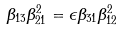Convert formula to latex. <formula><loc_0><loc_0><loc_500><loc_500>\beta _ { 1 3 } \beta _ { 2 1 } ^ { 2 } = \epsilon \beta _ { 3 1 } \beta _ { 1 2 } ^ { 2 }</formula> 